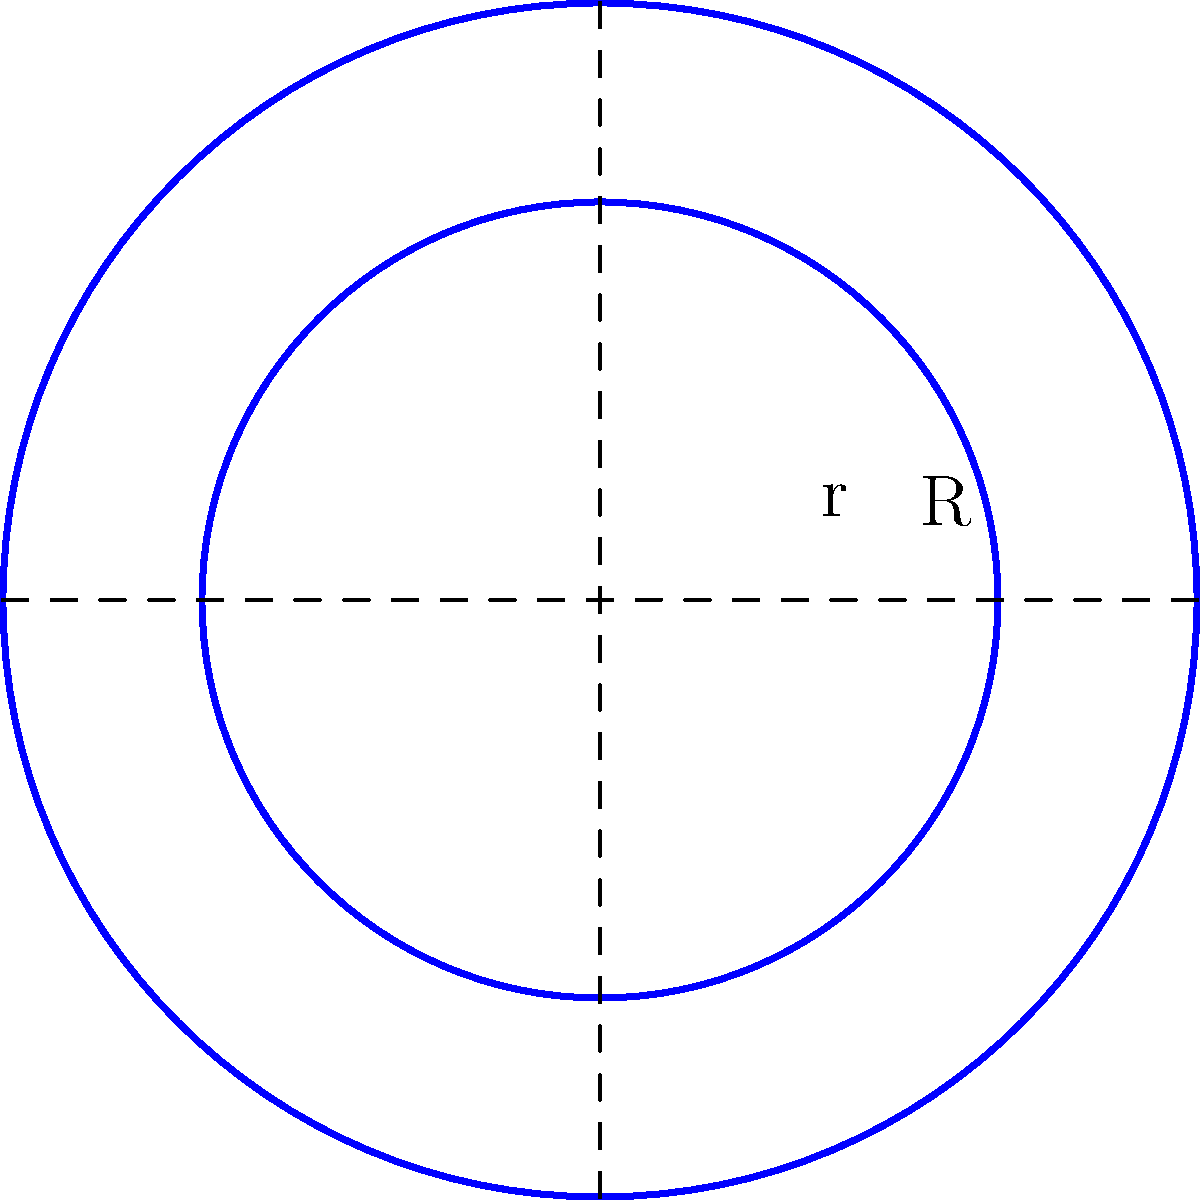As a concerned mother wanting your child to excel in swimming, you're researching pool safety equipment. You come across a circular lifesaver ring with an outer radius (R) of 15 inches and an inner radius (r) of 10 inches. What is the surface area of this lifesaver ring in square inches? Round your answer to the nearest whole number. Let's approach this step-by-step:

1) The surface area of a circular ring is the difference between the areas of two circles: the larger circle (outer) minus the smaller circle (inner).

2) The formula for the area of a circle is $A = \pi r^2$, where r is the radius.

3) For the outer circle:
   Area = $\pi R^2 = \pi (15^2) = 225\pi$ square inches

4) For the inner circle:
   Area = $\pi r^2 = \pi (10^2) = 100\pi$ square inches

5) The surface area of the ring is the difference:
   Surface Area = $225\pi - 100\pi = 125\pi$ square inches

6) Let's calculate this:
   $125\pi \approx 392.7$ square inches

7) Rounding to the nearest whole number:
   393 square inches
Answer: 393 square inches 